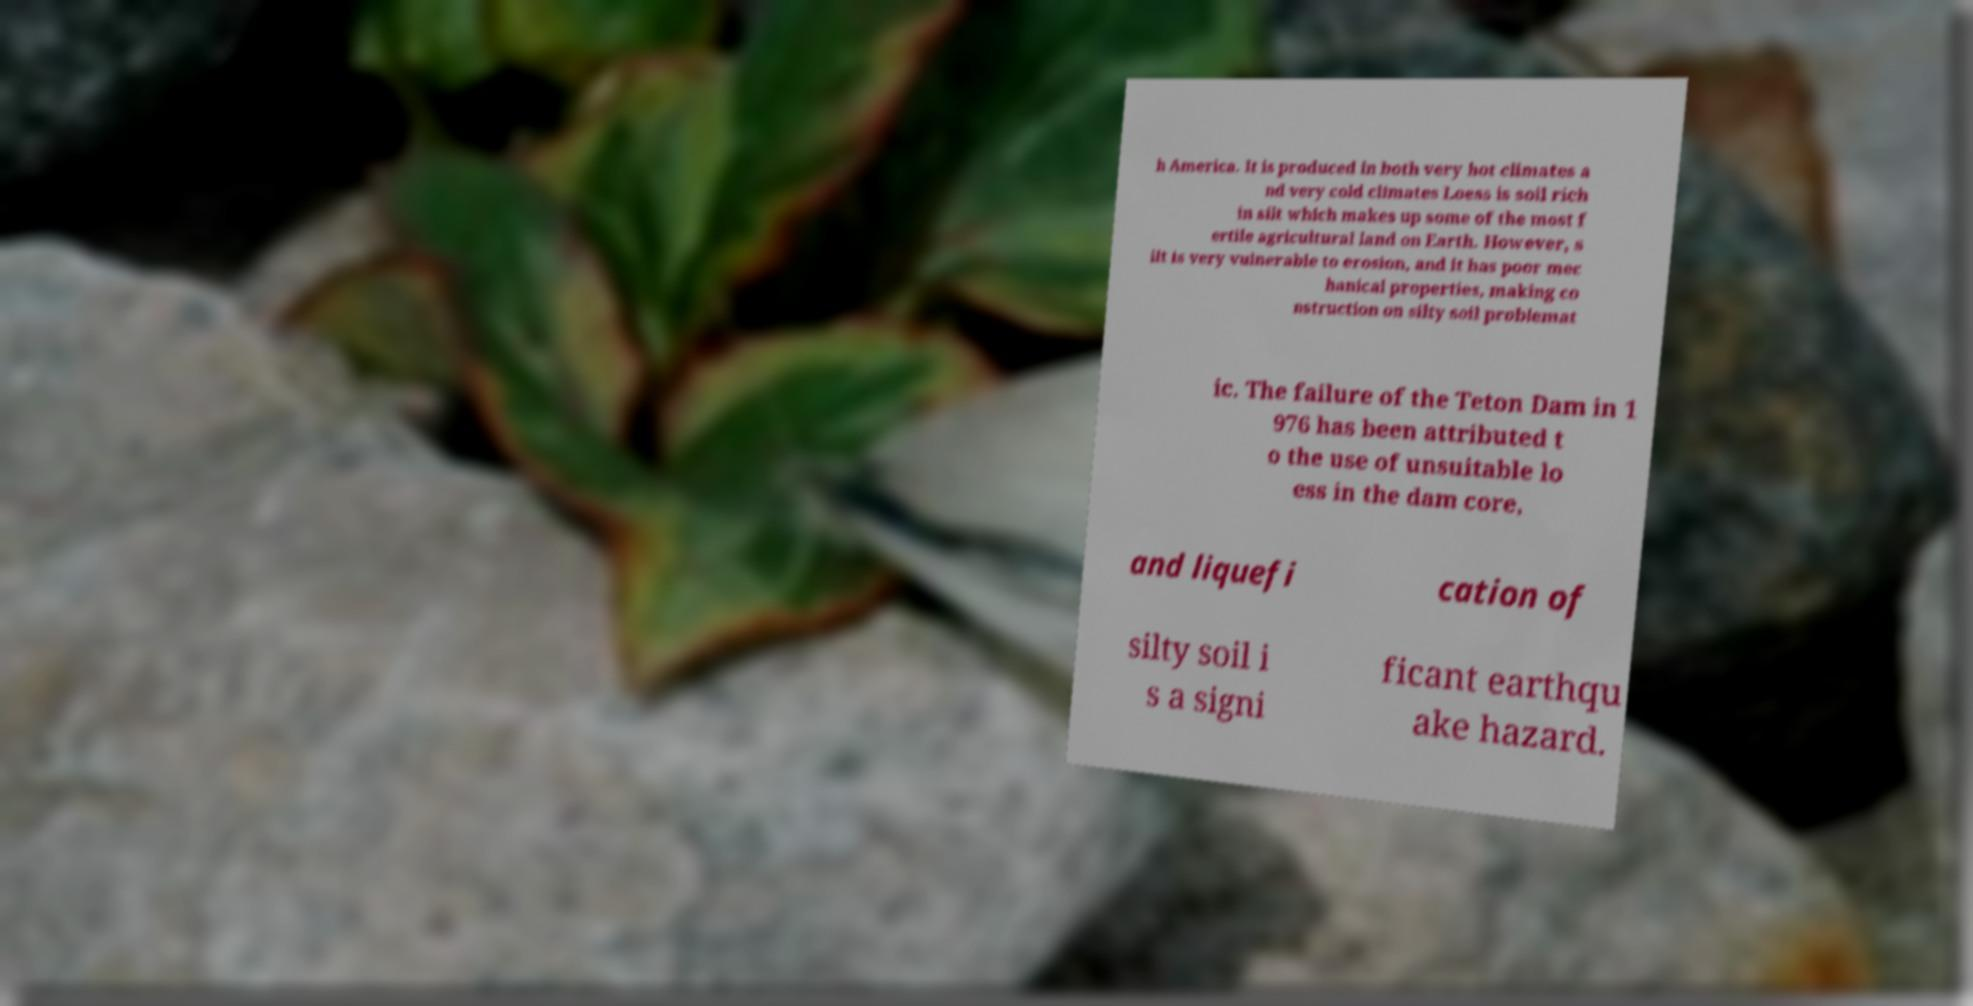I need the written content from this picture converted into text. Can you do that? h America. It is produced in both very hot climates a nd very cold climates Loess is soil rich in silt which makes up some of the most f ertile agricultural land on Earth. However, s ilt is very vulnerable to erosion, and it has poor mec hanical properties, making co nstruction on silty soil problemat ic. The failure of the Teton Dam in 1 976 has been attributed t o the use of unsuitable lo ess in the dam core, and liquefi cation of silty soil i s a signi ficant earthqu ake hazard. 